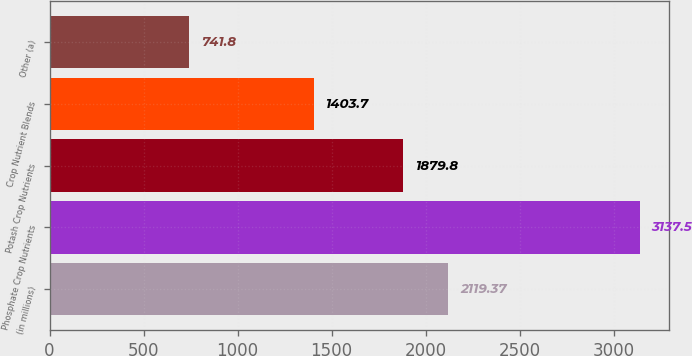Convert chart. <chart><loc_0><loc_0><loc_500><loc_500><bar_chart><fcel>(in millions)<fcel>Phosphate Crop Nutrients<fcel>Potash Crop Nutrients<fcel>Crop Nutrient Blends<fcel>Other (a)<nl><fcel>2119.37<fcel>3137.5<fcel>1879.8<fcel>1403.7<fcel>741.8<nl></chart> 